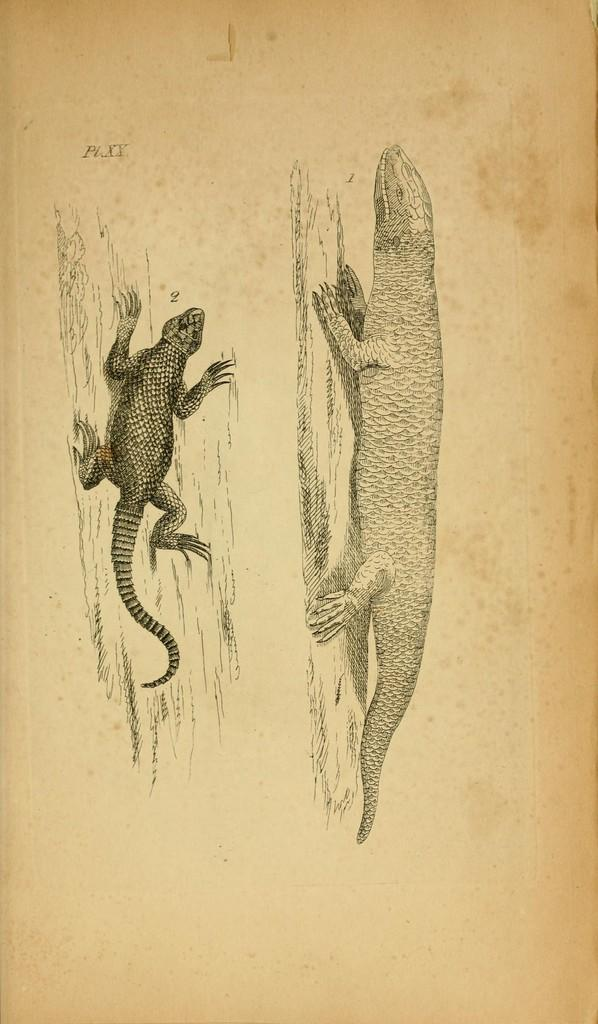What animals are depicted in the pictures in the image? There are pictures of two lizards in the image. What are the lizards resting on in the pictures? The lizards are on logs in the pictures. What surface do the pictures of the lizards appear on? The lizards are on a paper in the image. What can be found written on the paper in the image? There is text written on the paper in the image. How many mice are shown interacting with the lizards in the image? There are no mice present in the image; it features pictures of two lizards on logs. What type of farming equipment can be seen in the image? There is no farming equipment present in the image. 